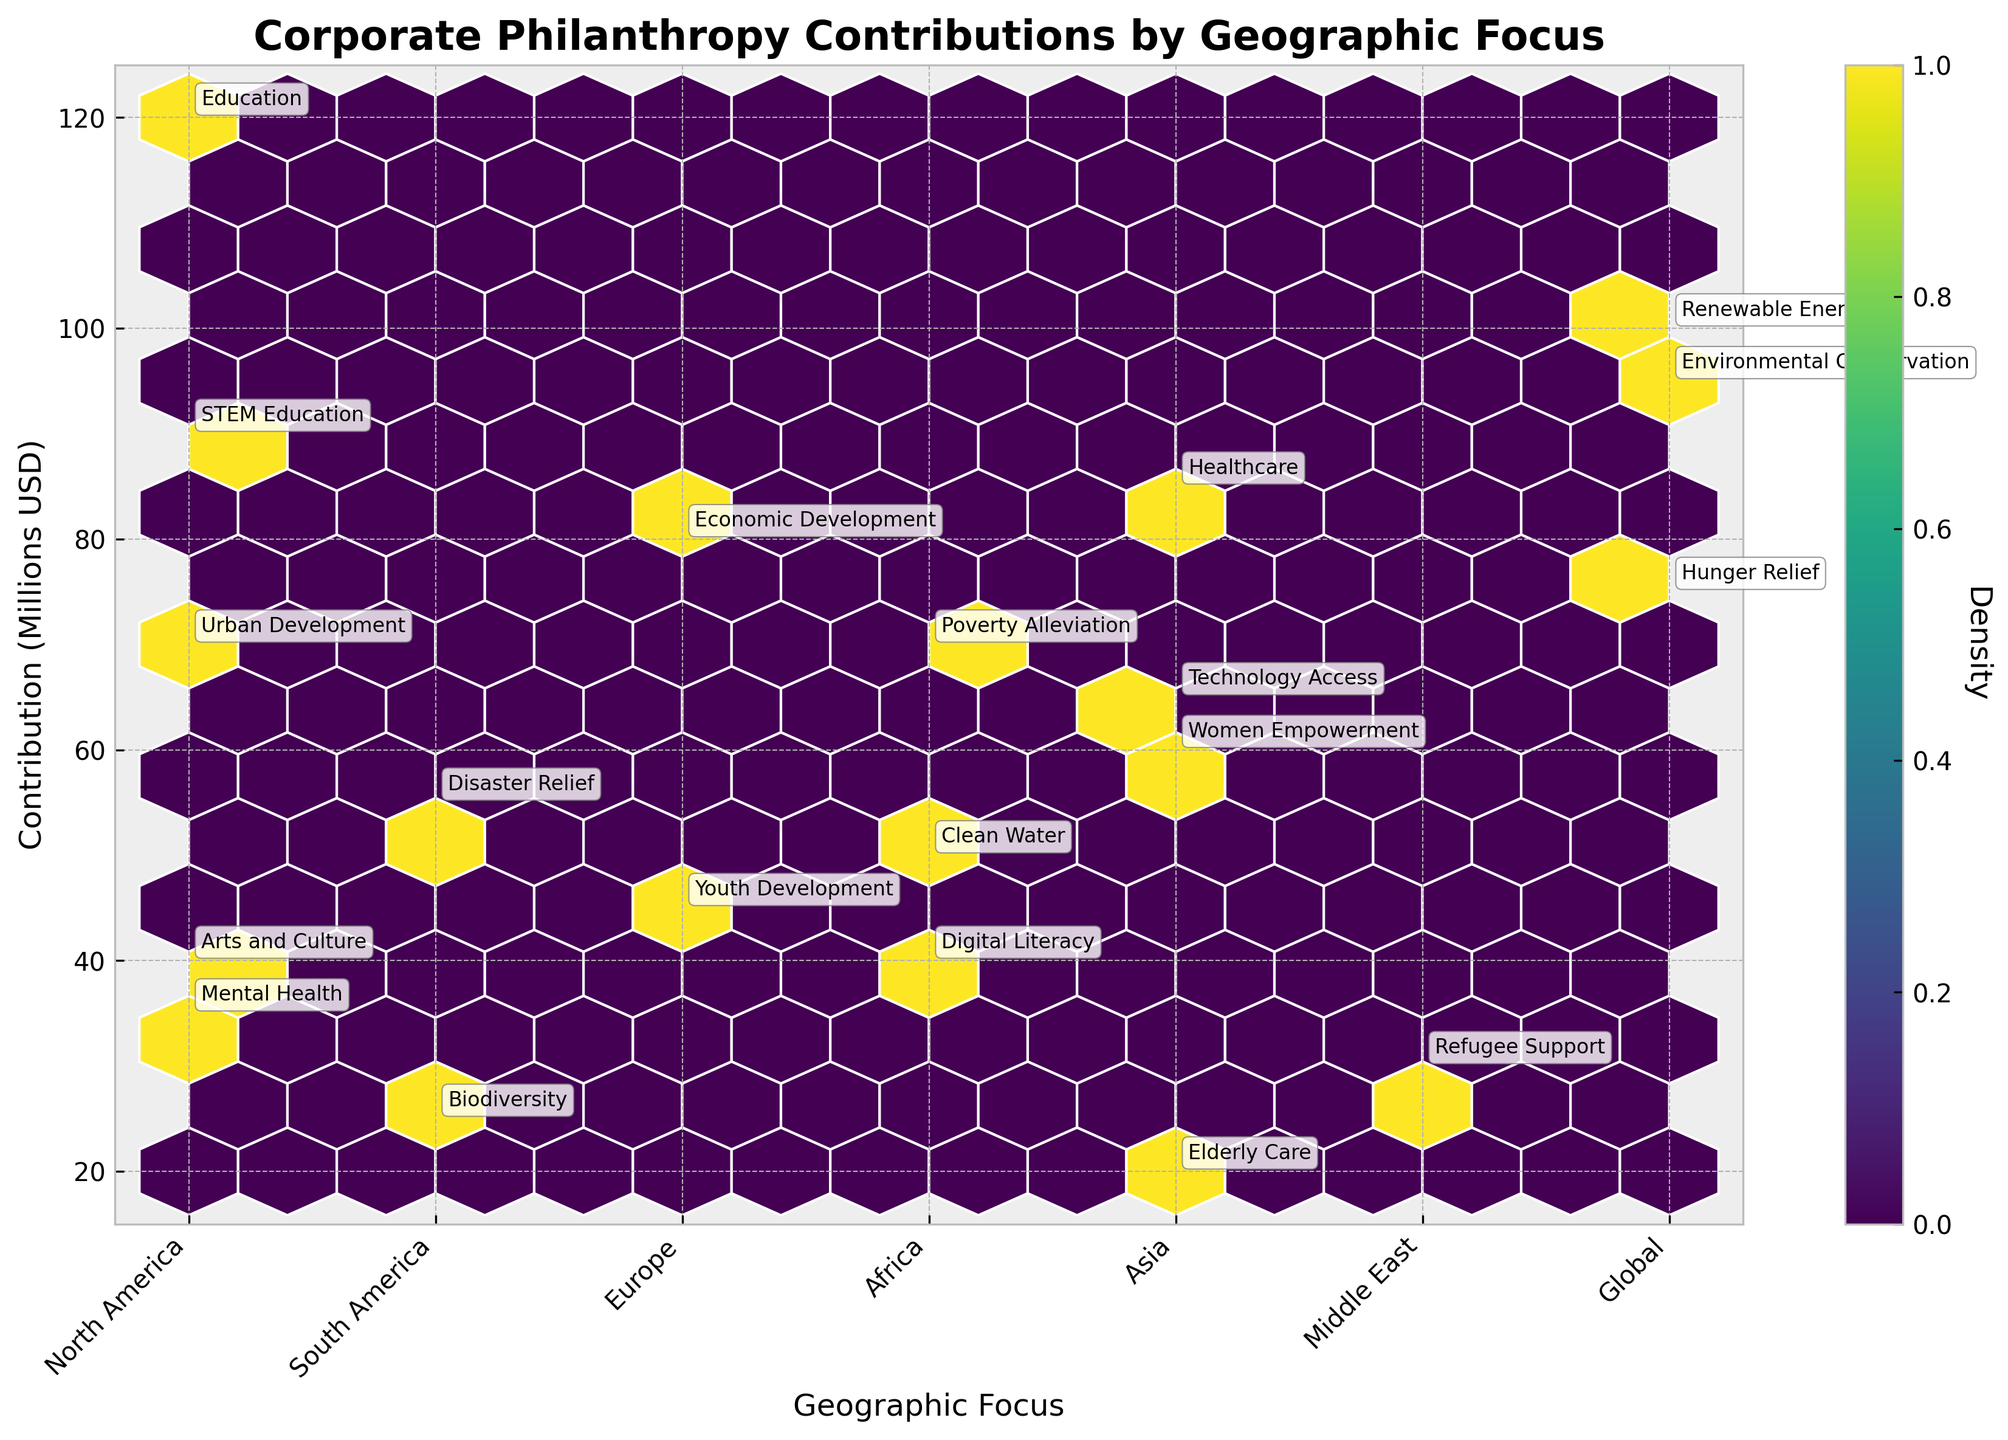What is the title of the plot? The title is usually displayed at the top of the plot, providing a brief description of the plotted data. In this case, it's "Corporate Philanthropy Contributions by Geographic Focus".
Answer: Corporate Philanthropy Contributions by Geographic Focus What is the y-axis label? The y-axis label describes the data measured along the vertical axis. In this plot, the y-axis label is "Contribution (Millions USD)".
Answer: Contribution (Millions USD) Which geographic focus area has the highest contribution? To identify the area with the highest contribution, look at the highest point along the y-axis and check its corresponding point on the x-axis, which is labeled as "Geographic Focus". The highest contribution point is around 120 million, belonging to "North America".
Answer: North America How many geographic focus areas are represented on the x-axis? By counting the distinct labels on the x-axis representing geographic focus areas, we find there are seven areas. These are: North America, South America, Europe, Africa, Asia, Middle East, and Global.
Answer: Seven What is the range of contributions made in North America? The contributions for North America can be observed by checking data points along the y-axis that align with the "North America" label on the x-axis. Contributions range from 35 to 120 million USD.
Answer: 35 to 120 million USD Which cause corresponds to the contribution of 95 million USD? The annotation on the plot for the data point at 95 million USD reveals that it is for the cause "Environmental Conservation".
Answer: Environmental Conservation Are contributions to the "Global" geographic focus area above 70 million USD? Yes, by looking at the x-axis label "Global" and identifying associated points on the plot, we can see that all contributions (75, 95, 100 million USD) are above 70 million USD.
Answer: Yes How many causes have contributions of 60 million USD or more in Asia? Checking the Asia label on the x-axis and identifying respective points, we see three points with contributions of 85, 65, and 60 million USD, corresponding to three causes categorized in Asia.
Answer: Three What is the overall highest contribution amount, and which cause and region does it belong to? The highest contribution amount is identified by the highest point on the y-axis, which is 120 million USD. The annotations indicate this is for "Education" in the "North America" region.
Answer: 120 million USD for Education in North America What is the density color for contributions around 70 million USD in Europe? The density indicated by the color on the hexbin plot around 70 million USD in Europe shows a light shade, indicating low density. By comparing the color to the color bar, it's clear this represents a lower density region.
Answer: Low density Which cause has the smallest contribution and where is it focused? By finding the annotation for the smallest y-axis value, we see the smallest contribution is 20 million USD, belonging to "Elderly Care" in "Asia".
Answer: Elderly Care in Asia 